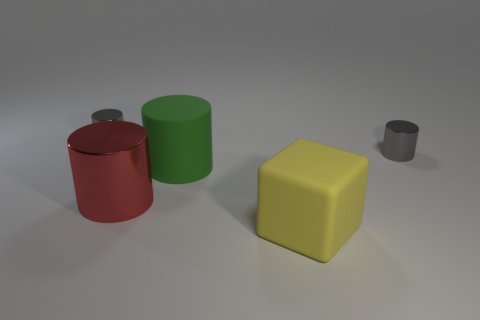Subtract all gray cylinders. How many were subtracted if there are1gray cylinders left? 1 Subtract all blocks. How many objects are left? 4 Subtract 1 blocks. How many blocks are left? 0 Subtract all green cylinders. Subtract all yellow balls. How many cylinders are left? 3 Subtract all purple cubes. How many red cylinders are left? 1 Subtract all big green metallic cylinders. Subtract all small gray cylinders. How many objects are left? 3 Add 2 big objects. How many big objects are left? 5 Add 2 big brown rubber cylinders. How many big brown rubber cylinders exist? 2 Add 4 big green cylinders. How many objects exist? 9 Subtract all green cylinders. How many cylinders are left? 3 